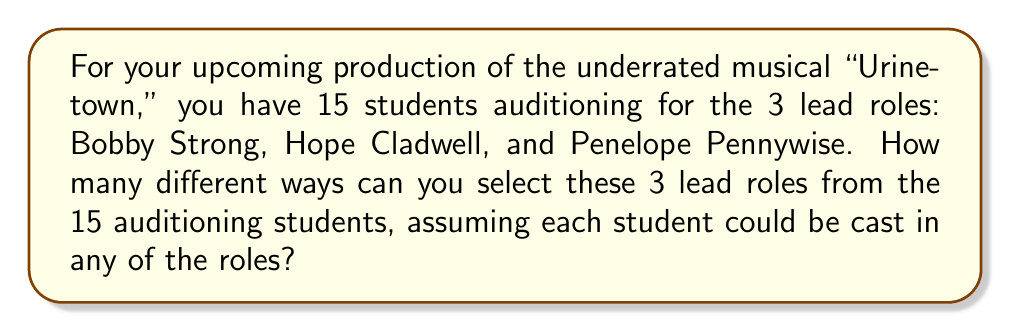Show me your answer to this math problem. To solve this problem, we need to use the concept of permutations. Here's why:

1. We are selecting 3 students from a group of 15.
2. The order matters because each selected student is assigned to a specific role.
3. We cannot select the same student for multiple roles.

This scenario fits the formula for permutations: $P(n,r) = \frac{n!}{(n-r)!}$

Where:
$n$ = total number of items to choose from (15 students)
$r$ = number of items being chosen (3 roles)

Let's plug in the numbers:

$$P(15,3) = \frac{15!}{(15-3)!} = \frac{15!}{12!}$$

Now, let's calculate:

$$\frac{15!}{12!} = 15 \times 14 \times 13 = 2730$$

This can be broken down as follows:
- For the first role, we have 15 choices
- For the second role, we have 14 remaining choices
- For the third role, we have 13 remaining choices

Multiplying these together gives us the total number of possible arrangements.
Answer: 2730 ways 